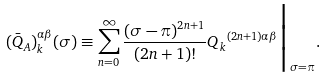<formula> <loc_0><loc_0><loc_500><loc_500>( { \bar { Q } } _ { A } ) ^ { \alpha \beta } _ { k } ( \sigma ) \equiv \sum _ { n = 0 } ^ { \infty } \frac { ( \sigma - \pi ) ^ { 2 n + 1 } } { ( 2 n + 1 ) ! } { Q _ { k } } ^ { ( 2 n + 1 ) \alpha \beta } \Big { | } _ { \sigma = \pi } .</formula> 